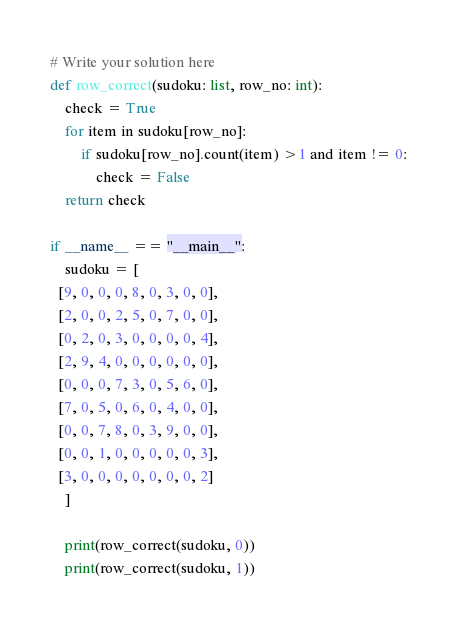<code> <loc_0><loc_0><loc_500><loc_500><_Python_># Write your solution here
def row_correct(sudoku: list, row_no: int):
    check = True
    for item in sudoku[row_no]:
        if sudoku[row_no].count(item) >1 and item != 0:
            check = False 
    return check

if __name__ == "__main__":
    sudoku = [
  [9, 0, 0, 0, 8, 0, 3, 0, 0],
  [2, 0, 0, 2, 5, 0, 7, 0, 0],
  [0, 2, 0, 3, 0, 0, 0, 0, 4],
  [2, 9, 4, 0, 0, 0, 0, 0, 0],
  [0, 0, 0, 7, 3, 0, 5, 6, 0],
  [7, 0, 5, 0, 6, 0, 4, 0, 0],
  [0, 0, 7, 8, 0, 3, 9, 0, 0],
  [0, 0, 1, 0, 0, 0, 0, 0, 3],
  [3, 0, 0, 0, 0, 0, 0, 0, 2]
    ]

    print(row_correct(sudoku, 0))
    print(row_correct(sudoku, 1))</code> 